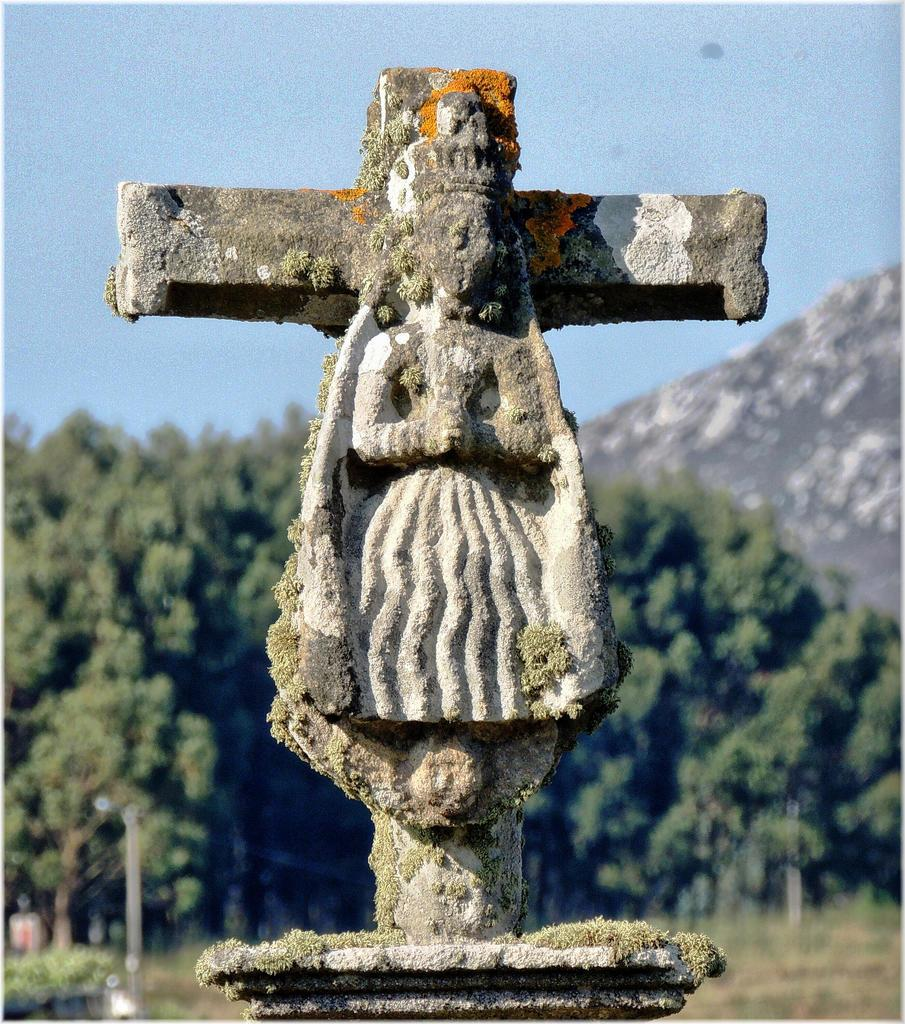What is the main subject of the image? There is a stone carving in the image. What can be seen in the background of the image? There is sky, trees, and a hill visible in the background of the image. What type of cake is being served at the birthday party in the image? There is no birthday party or cake present in the image; it features a stone carving and a background with sky, trees, and a hill. 